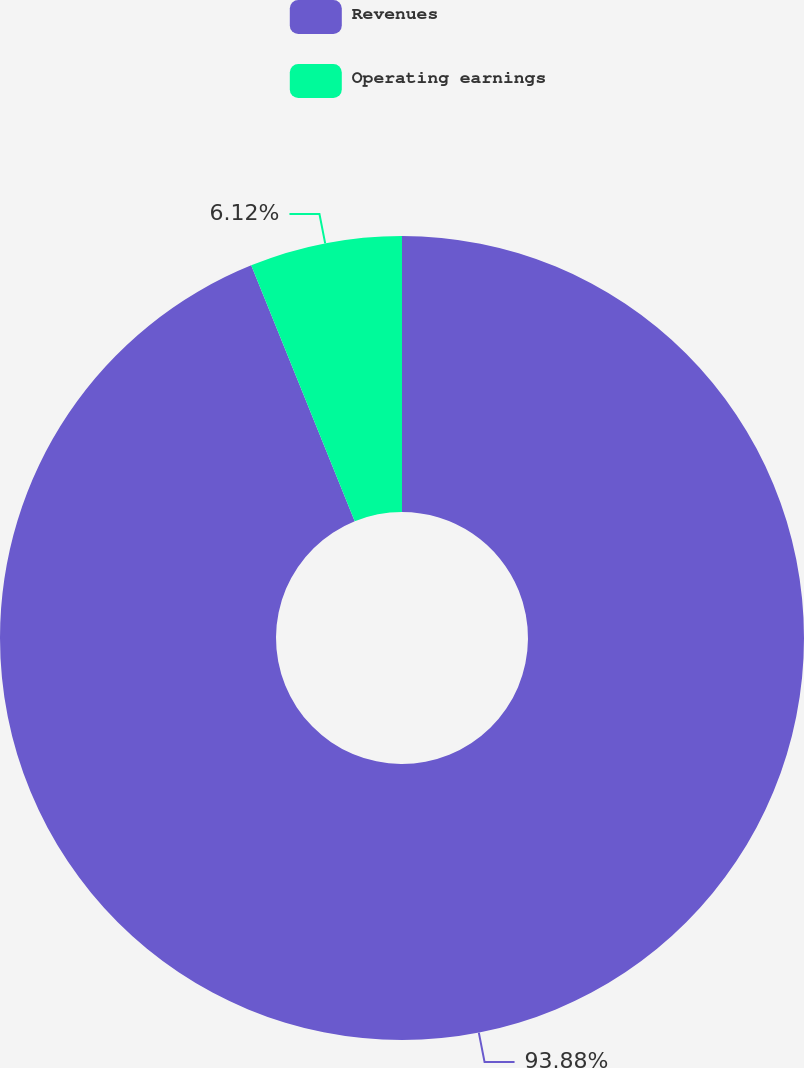Convert chart. <chart><loc_0><loc_0><loc_500><loc_500><pie_chart><fcel>Revenues<fcel>Operating earnings<nl><fcel>93.88%<fcel>6.12%<nl></chart> 